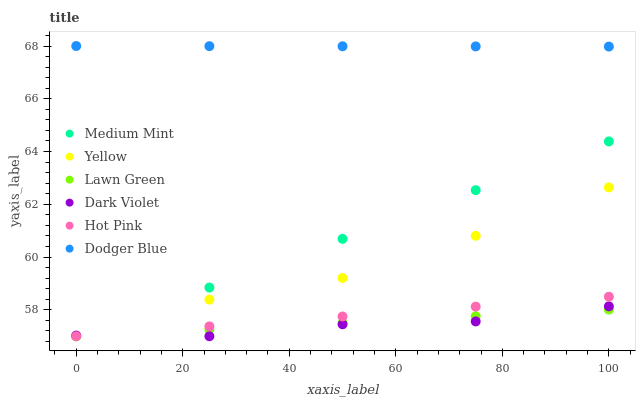Does Dark Violet have the minimum area under the curve?
Answer yes or no. Yes. Does Dodger Blue have the maximum area under the curve?
Answer yes or no. Yes. Does Lawn Green have the minimum area under the curve?
Answer yes or no. No. Does Lawn Green have the maximum area under the curve?
Answer yes or no. No. Is Medium Mint the smoothest?
Answer yes or no. Yes. Is Yellow the roughest?
Answer yes or no. Yes. Is Lawn Green the smoothest?
Answer yes or no. No. Is Lawn Green the roughest?
Answer yes or no. No. Does Medium Mint have the lowest value?
Answer yes or no. Yes. Does Dodger Blue have the lowest value?
Answer yes or no. No. Does Dodger Blue have the highest value?
Answer yes or no. Yes. Does Hot Pink have the highest value?
Answer yes or no. No. Is Dark Violet less than Dodger Blue?
Answer yes or no. Yes. Is Dodger Blue greater than Lawn Green?
Answer yes or no. Yes. Does Lawn Green intersect Dark Violet?
Answer yes or no. Yes. Is Lawn Green less than Dark Violet?
Answer yes or no. No. Is Lawn Green greater than Dark Violet?
Answer yes or no. No. Does Dark Violet intersect Dodger Blue?
Answer yes or no. No. 